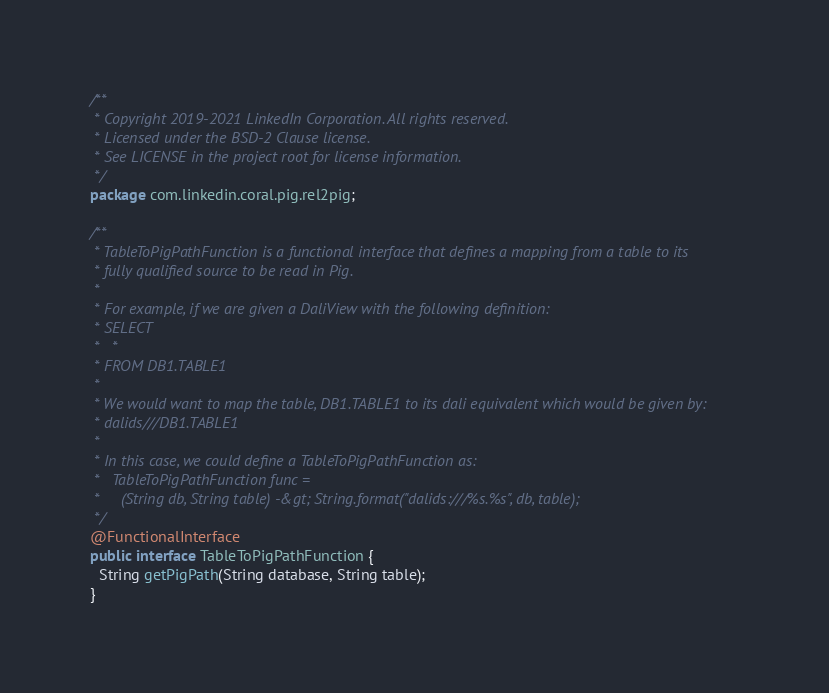Convert code to text. <code><loc_0><loc_0><loc_500><loc_500><_Java_>/**
 * Copyright 2019-2021 LinkedIn Corporation. All rights reserved.
 * Licensed under the BSD-2 Clause license.
 * See LICENSE in the project root for license information.
 */
package com.linkedin.coral.pig.rel2pig;

/**
 * TableToPigPathFunction is a functional interface that defines a mapping from a table to its
 * fully qualified source to be read in Pig.
 *
 * For example, if we are given a DaliView with the following definition:
 * SELECT
 *   *
 * FROM DB1.TABLE1
 *
 * We would want to map the table, DB1.TABLE1 to its dali equivalent which would be given by:
 * dalids///DB1.TABLE1
 *
 * In this case, we could define a TableToPigPathFunction as:
 *   TableToPigPathFunction func =
 *     (String db, String table) -&gt; String.format("dalids:///%s.%s", db, table);
 */
@FunctionalInterface
public interface TableToPigPathFunction {
  String getPigPath(String database, String table);
}
</code> 